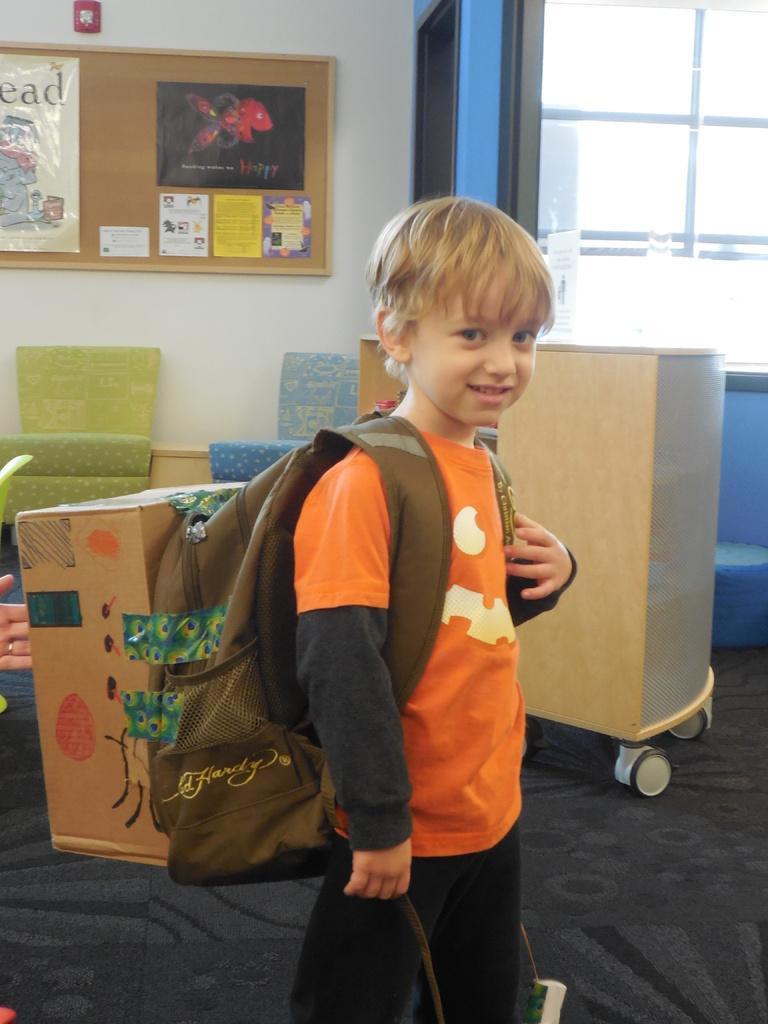Could you give a brief overview of what you see in this image? In this image we can see a boy wearing a bag. In the background of the image there is window. There is wall with a board and posters on it. There are chairs. There is a box with tires. At the bottom of the image there is carpet. 